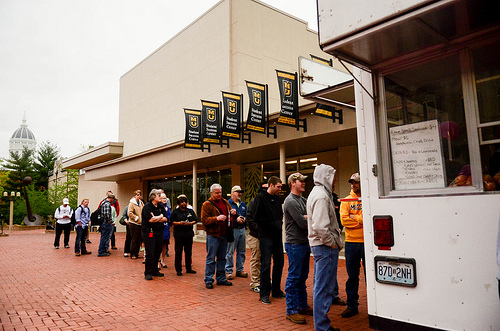<image>
Is the man to the right of the man? No. The man is not to the right of the man. The horizontal positioning shows a different relationship. 